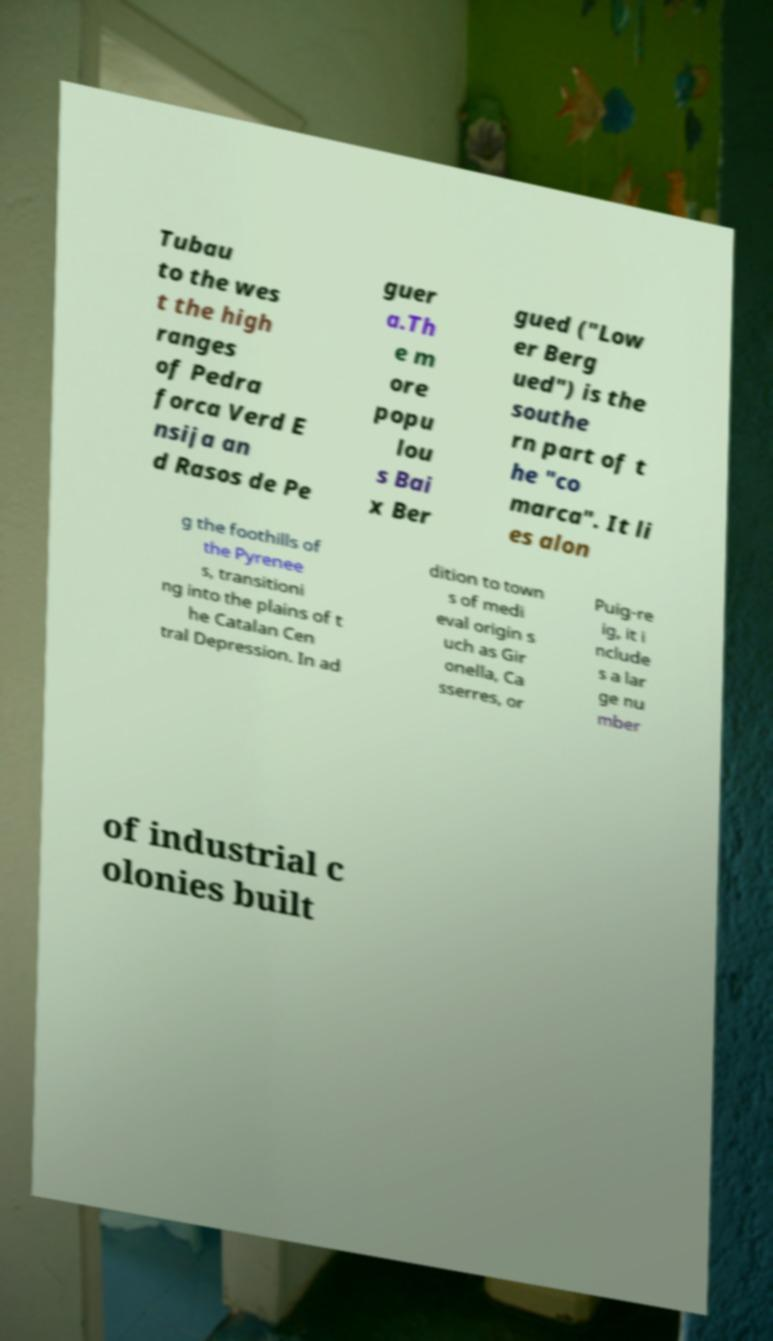Please identify and transcribe the text found in this image. Tubau to the wes t the high ranges of Pedra forca Verd E nsija an d Rasos de Pe guer a.Th e m ore popu lou s Bai x Ber gued ("Low er Berg ued") is the southe rn part of t he "co marca". It li es alon g the foothills of the Pyrenee s, transitioni ng into the plains of t he Catalan Cen tral Depression. In ad dition to town s of medi eval origin s uch as Gir onella, Ca sserres, or Puig-re ig, it i nclude s a lar ge nu mber of industrial c olonies built 